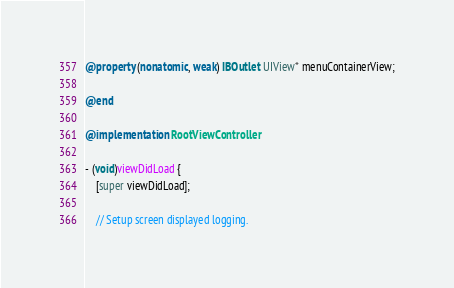Convert code to text. <code><loc_0><loc_0><loc_500><loc_500><_ObjectiveC_>@property (nonatomic, weak) IBOutlet UIView* menuContainerView;

@end

@implementation RootViewController

- (void)viewDidLoad {
    [super viewDidLoad];

    // Setup screen displayed logging.</code> 